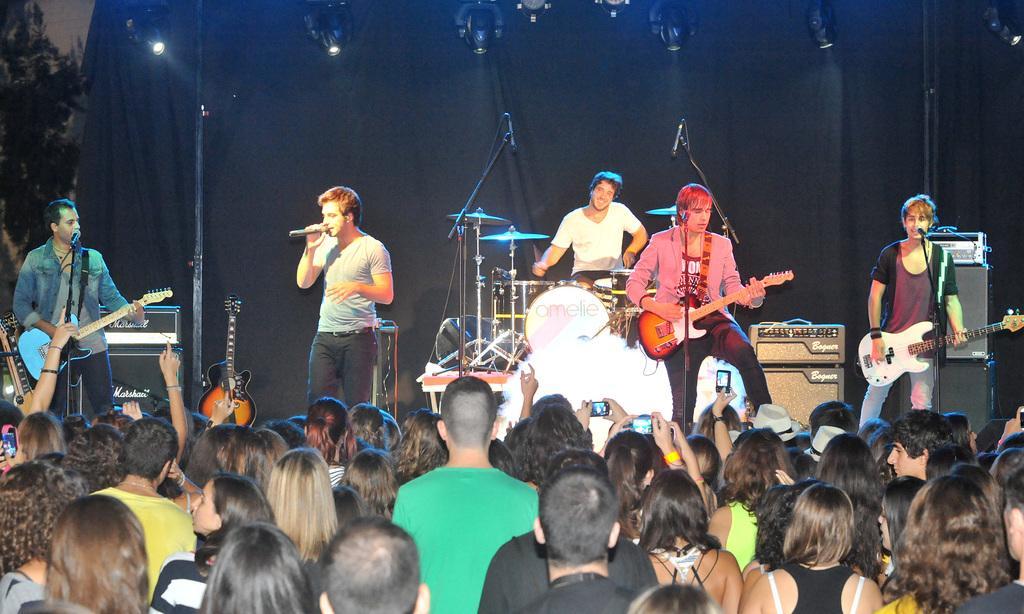In one or two sentences, can you explain what this image depicts? In the center of the image there are persons standing and performing on dais. On the right side of the image we can see a person holding a guitar. On the left side of the image we can see a guitar, speaker and a person holding a guitar. At the bottom there is a crowd. In the background there is a person with musical equipment, curtain, lights and sky. 